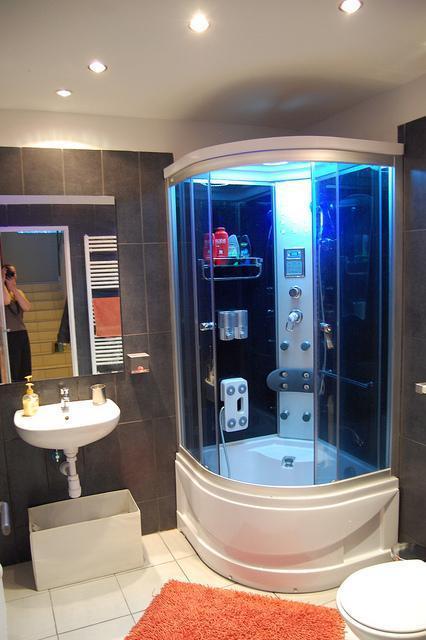How many bath products are on the top rack in the shower?
Give a very brief answer. 3. 